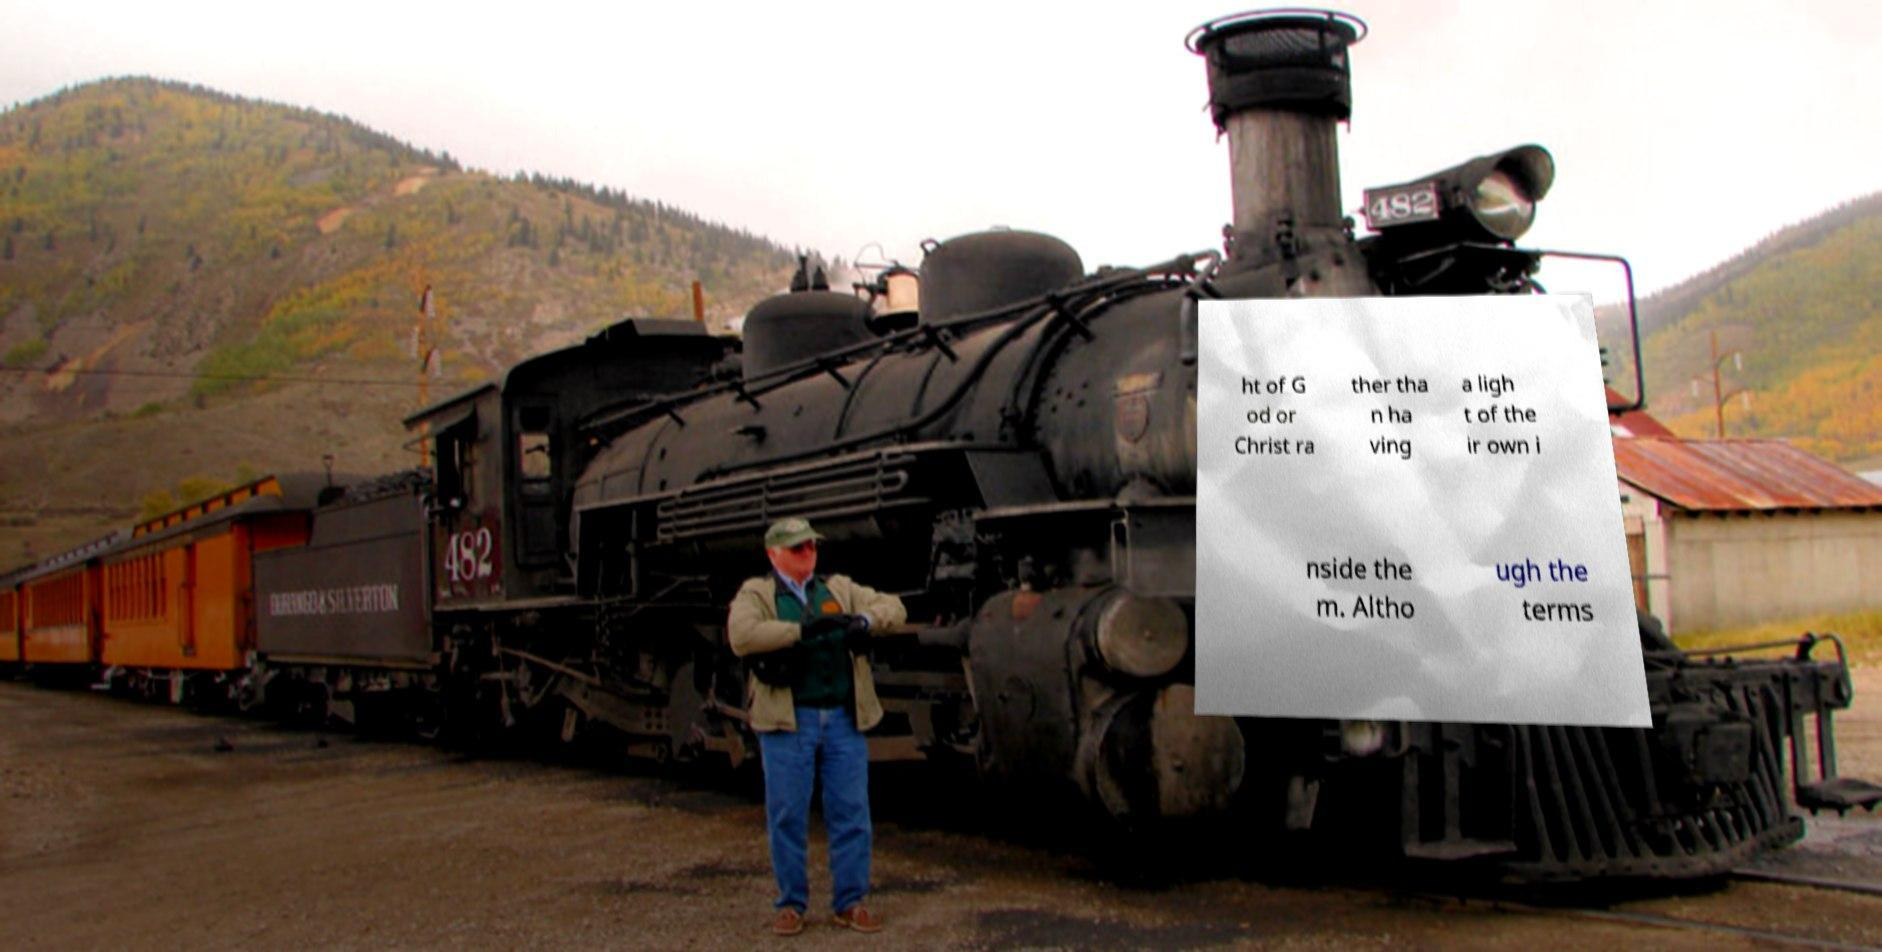Could you assist in decoding the text presented in this image and type it out clearly? ht of G od or Christ ra ther tha n ha ving a ligh t of the ir own i nside the m. Altho ugh the terms 